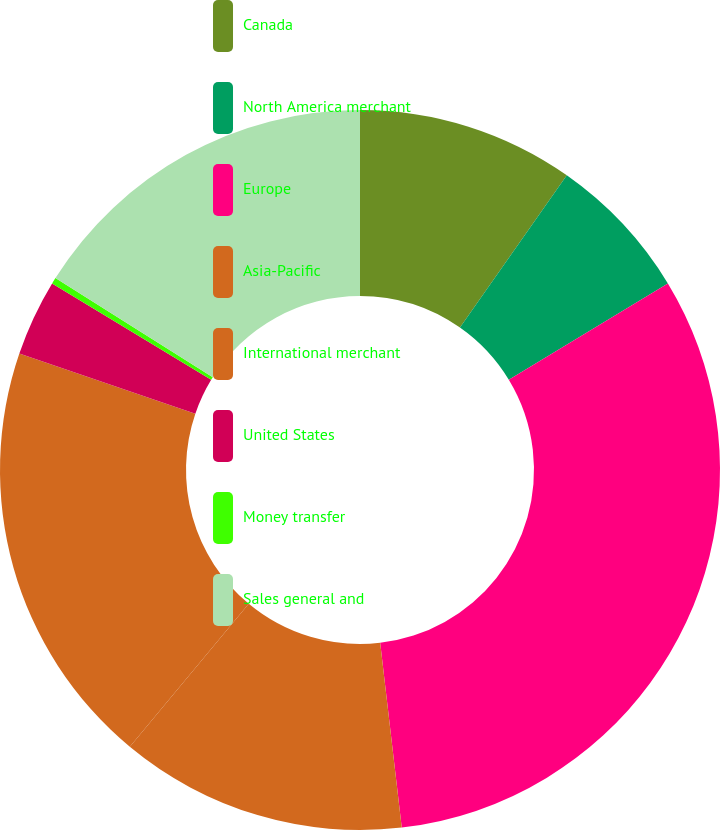Convert chart to OTSL. <chart><loc_0><loc_0><loc_500><loc_500><pie_chart><fcel>Canada<fcel>North America merchant<fcel>Europe<fcel>Asia-Pacific<fcel>International merchant<fcel>United States<fcel>Money transfer<fcel>Sales general and<nl><fcel>9.74%<fcel>6.59%<fcel>31.82%<fcel>12.89%<fcel>19.2%<fcel>3.43%<fcel>0.28%<fcel>16.05%<nl></chart> 